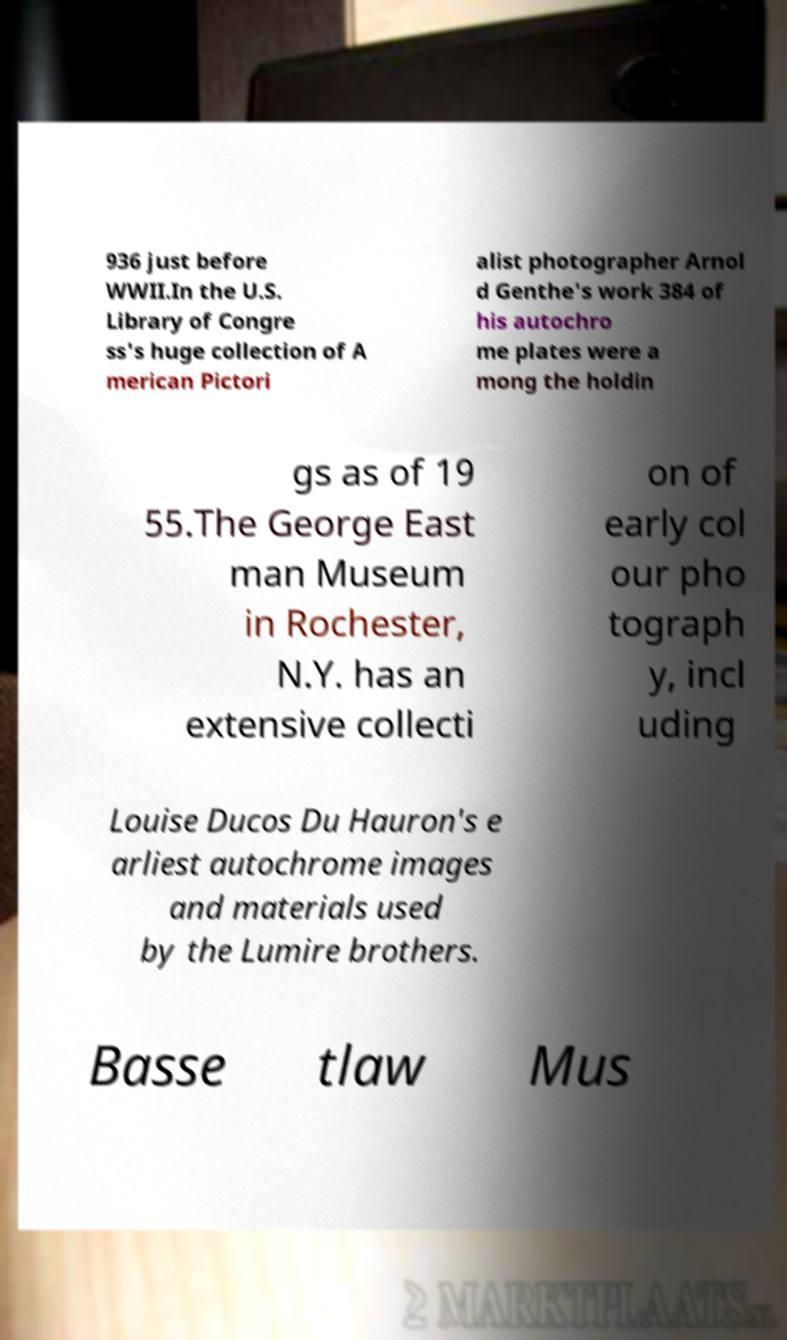There's text embedded in this image that I need extracted. Can you transcribe it verbatim? 936 just before WWII.In the U.S. Library of Congre ss's huge collection of A merican Pictori alist photographer Arnol d Genthe's work 384 of his autochro me plates were a mong the holdin gs as of 19 55.The George East man Museum in Rochester, N.Y. has an extensive collecti on of early col our pho tograph y, incl uding Louise Ducos Du Hauron's e arliest autochrome images and materials used by the Lumire brothers. Basse tlaw Mus 